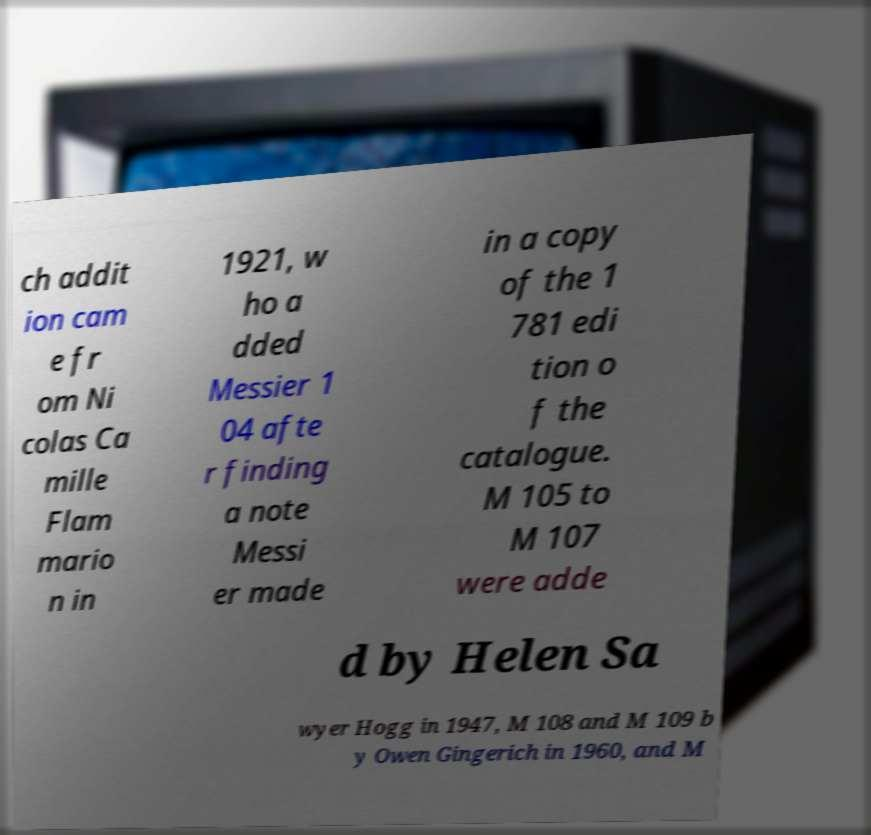Could you extract and type out the text from this image? ch addit ion cam e fr om Ni colas Ca mille Flam mario n in 1921, w ho a dded Messier 1 04 afte r finding a note Messi er made in a copy of the 1 781 edi tion o f the catalogue. M 105 to M 107 were adde d by Helen Sa wyer Hogg in 1947, M 108 and M 109 b y Owen Gingerich in 1960, and M 